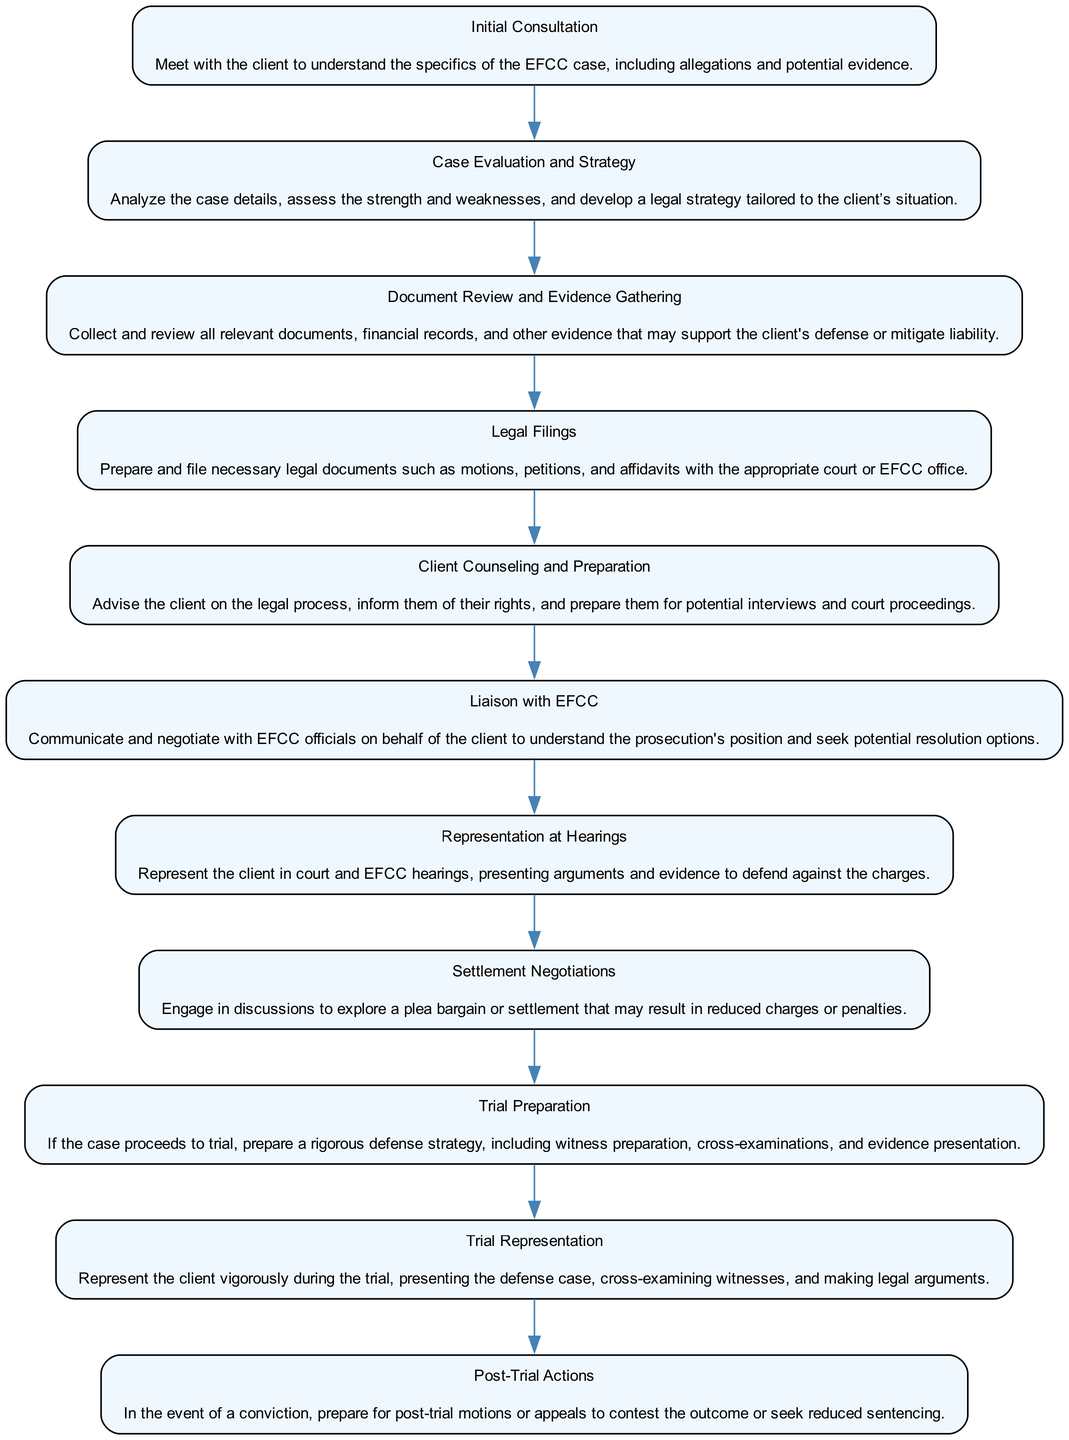What is the first step in representing a client in EFCC cases? The first step is indicated at the top of the flow chart, which is "Initial Consultation".
Answer: Initial Consultation How many steps are involved in the process? The total number of steps can be counted in the flow chart; there are ten distinct steps listed.
Answer: 10 Which step comes after "Document Review and Evidence Gathering"? To find the answer, we need to locate "Document Review and Evidence Gathering" and look at the flow to see what follows it, which is "Legal Filings".
Answer: Legal Filings What is the last step after "Trial Representation"? The last step in the flow chart is generally at the bottom, which is "Post-Trial Actions".
Answer: Post-Trial Actions Which step involves negotiating with EFCC officials? The step that specifically mentions communicating and negotiating with EFCC officials is titled "Liaison with EFCC".
Answer: Liaison with EFCC What step precedes "Settlement Negotiations"? To determine the preceding step, we check the flow and find that it comes just after "Representation at Hearings".
Answer: Representation at Hearings How many steps involve client preparation or counseling? We can identify steps related to client preparation by examining the titles; "Client Counseling and Preparation" is the primary step that focuses on this.
Answer: 1 What is the process described in the step "Trial Preparation"? This step describes preparing a rigorous defense strategy, including witness preparation, cross-examinations, and evidence presentation.
Answer: Preparing a rigorous defense strategy Which step mentions the potential for reduced charges? The step that discusses exploring a plea bargain or settlement that may lead to reduced charges is "Settlement Negotiations".
Answer: Settlement Negotiations What key activity is involved in "Case Evaluation and Strategy"? In this step, the key activity is analyzing case details and developing a tailored legal strategy.
Answer: Analyzing case details 